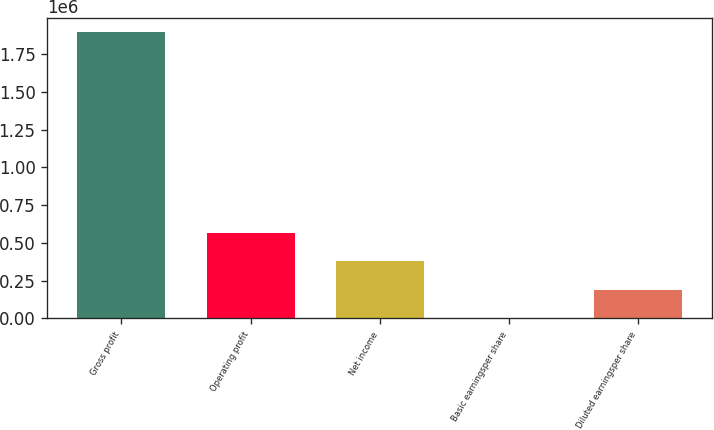Convert chart. <chart><loc_0><loc_0><loc_500><loc_500><bar_chart><fcel>Gross profit<fcel>Operating profit<fcel>Net income<fcel>Basic earningsper share<fcel>Diluted earningsper share<nl><fcel>1.89506e+06<fcel>568519<fcel>379013<fcel>1.26<fcel>189507<nl></chart> 